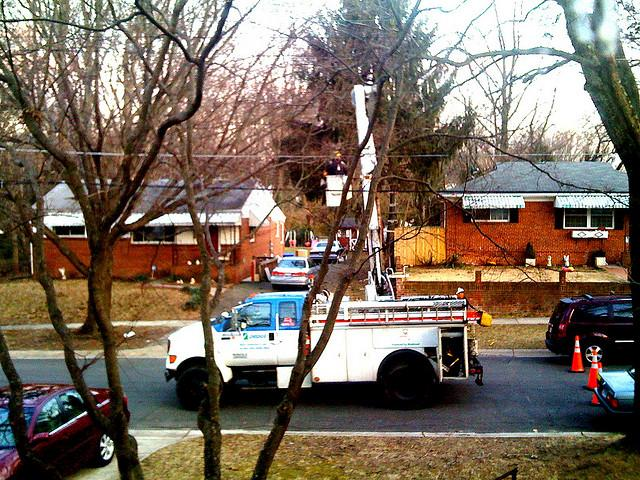Who is the man in the white platform?

Choices:
A) firefighter
B) policeman
C) utility worker
D) stuntman utility worker 